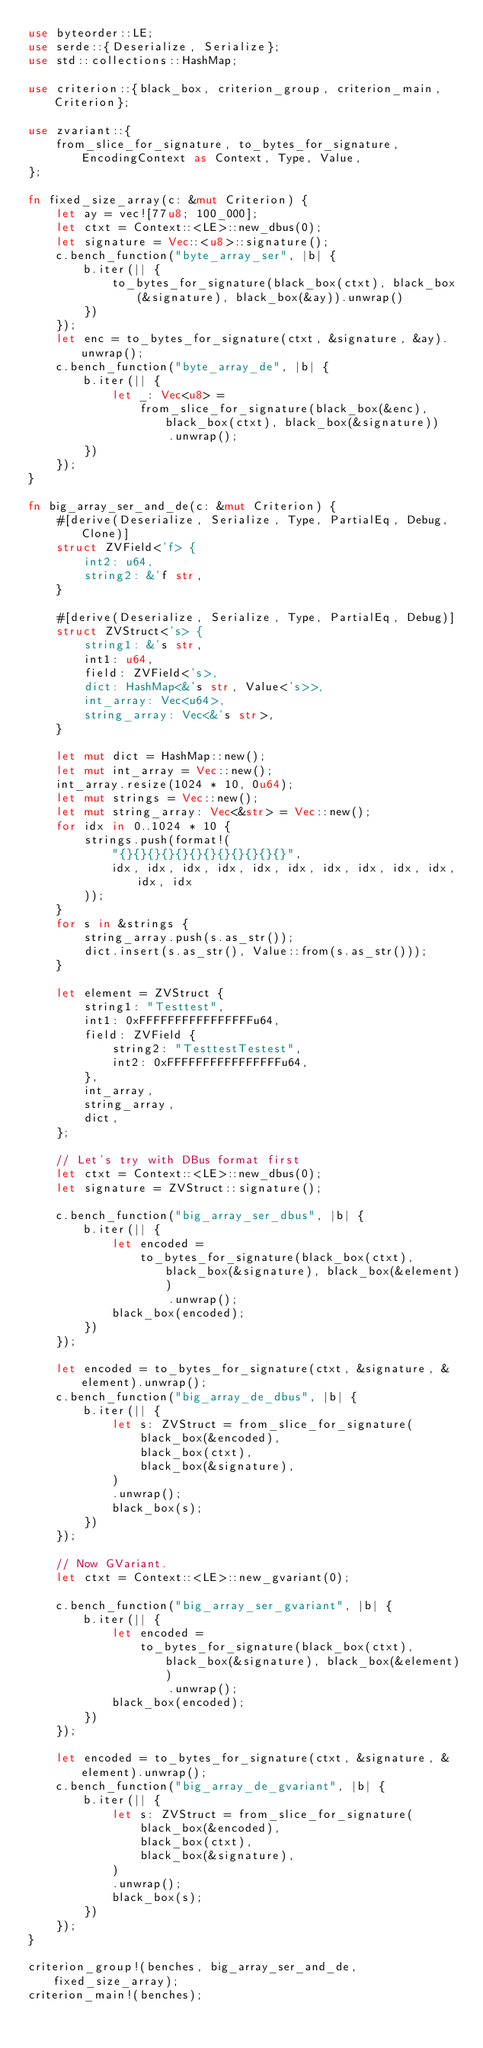<code> <loc_0><loc_0><loc_500><loc_500><_Rust_>use byteorder::LE;
use serde::{Deserialize, Serialize};
use std::collections::HashMap;

use criterion::{black_box, criterion_group, criterion_main, Criterion};

use zvariant::{
    from_slice_for_signature, to_bytes_for_signature, EncodingContext as Context, Type, Value,
};

fn fixed_size_array(c: &mut Criterion) {
    let ay = vec![77u8; 100_000];
    let ctxt = Context::<LE>::new_dbus(0);
    let signature = Vec::<u8>::signature();
    c.bench_function("byte_array_ser", |b| {
        b.iter(|| {
            to_bytes_for_signature(black_box(ctxt), black_box(&signature), black_box(&ay)).unwrap()
        })
    });
    let enc = to_bytes_for_signature(ctxt, &signature, &ay).unwrap();
    c.bench_function("byte_array_de", |b| {
        b.iter(|| {
            let _: Vec<u8> =
                from_slice_for_signature(black_box(&enc), black_box(ctxt), black_box(&signature))
                    .unwrap();
        })
    });
}

fn big_array_ser_and_de(c: &mut Criterion) {
    #[derive(Deserialize, Serialize, Type, PartialEq, Debug, Clone)]
    struct ZVField<'f> {
        int2: u64,
        string2: &'f str,
    }

    #[derive(Deserialize, Serialize, Type, PartialEq, Debug)]
    struct ZVStruct<'s> {
        string1: &'s str,
        int1: u64,
        field: ZVField<'s>,
        dict: HashMap<&'s str, Value<'s>>,
        int_array: Vec<u64>,
        string_array: Vec<&'s str>,
    }

    let mut dict = HashMap::new();
    let mut int_array = Vec::new();
    int_array.resize(1024 * 10, 0u64);
    let mut strings = Vec::new();
    let mut string_array: Vec<&str> = Vec::new();
    for idx in 0..1024 * 10 {
        strings.push(format!(
            "{}{}{}{}{}{}{}{}{}{}{}{}",
            idx, idx, idx, idx, idx, idx, idx, idx, idx, idx, idx, idx
        ));
    }
    for s in &strings {
        string_array.push(s.as_str());
        dict.insert(s.as_str(), Value::from(s.as_str()));
    }

    let element = ZVStruct {
        string1: "Testtest",
        int1: 0xFFFFFFFFFFFFFFFFu64,
        field: ZVField {
            string2: "TesttestTestest",
            int2: 0xFFFFFFFFFFFFFFFFu64,
        },
        int_array,
        string_array,
        dict,
    };

    // Let's try with DBus format first
    let ctxt = Context::<LE>::new_dbus(0);
    let signature = ZVStruct::signature();

    c.bench_function("big_array_ser_dbus", |b| {
        b.iter(|| {
            let encoded =
                to_bytes_for_signature(black_box(ctxt), black_box(&signature), black_box(&element))
                    .unwrap();
            black_box(encoded);
        })
    });

    let encoded = to_bytes_for_signature(ctxt, &signature, &element).unwrap();
    c.bench_function("big_array_de_dbus", |b| {
        b.iter(|| {
            let s: ZVStruct = from_slice_for_signature(
                black_box(&encoded),
                black_box(ctxt),
                black_box(&signature),
            )
            .unwrap();
            black_box(s);
        })
    });

    // Now GVariant.
    let ctxt = Context::<LE>::new_gvariant(0);

    c.bench_function("big_array_ser_gvariant", |b| {
        b.iter(|| {
            let encoded =
                to_bytes_for_signature(black_box(ctxt), black_box(&signature), black_box(&element))
                    .unwrap();
            black_box(encoded);
        })
    });

    let encoded = to_bytes_for_signature(ctxt, &signature, &element).unwrap();
    c.bench_function("big_array_de_gvariant", |b| {
        b.iter(|| {
            let s: ZVStruct = from_slice_for_signature(
                black_box(&encoded),
                black_box(ctxt),
                black_box(&signature),
            )
            .unwrap();
            black_box(s);
        })
    });
}

criterion_group!(benches, big_array_ser_and_de, fixed_size_array);
criterion_main!(benches);
</code> 